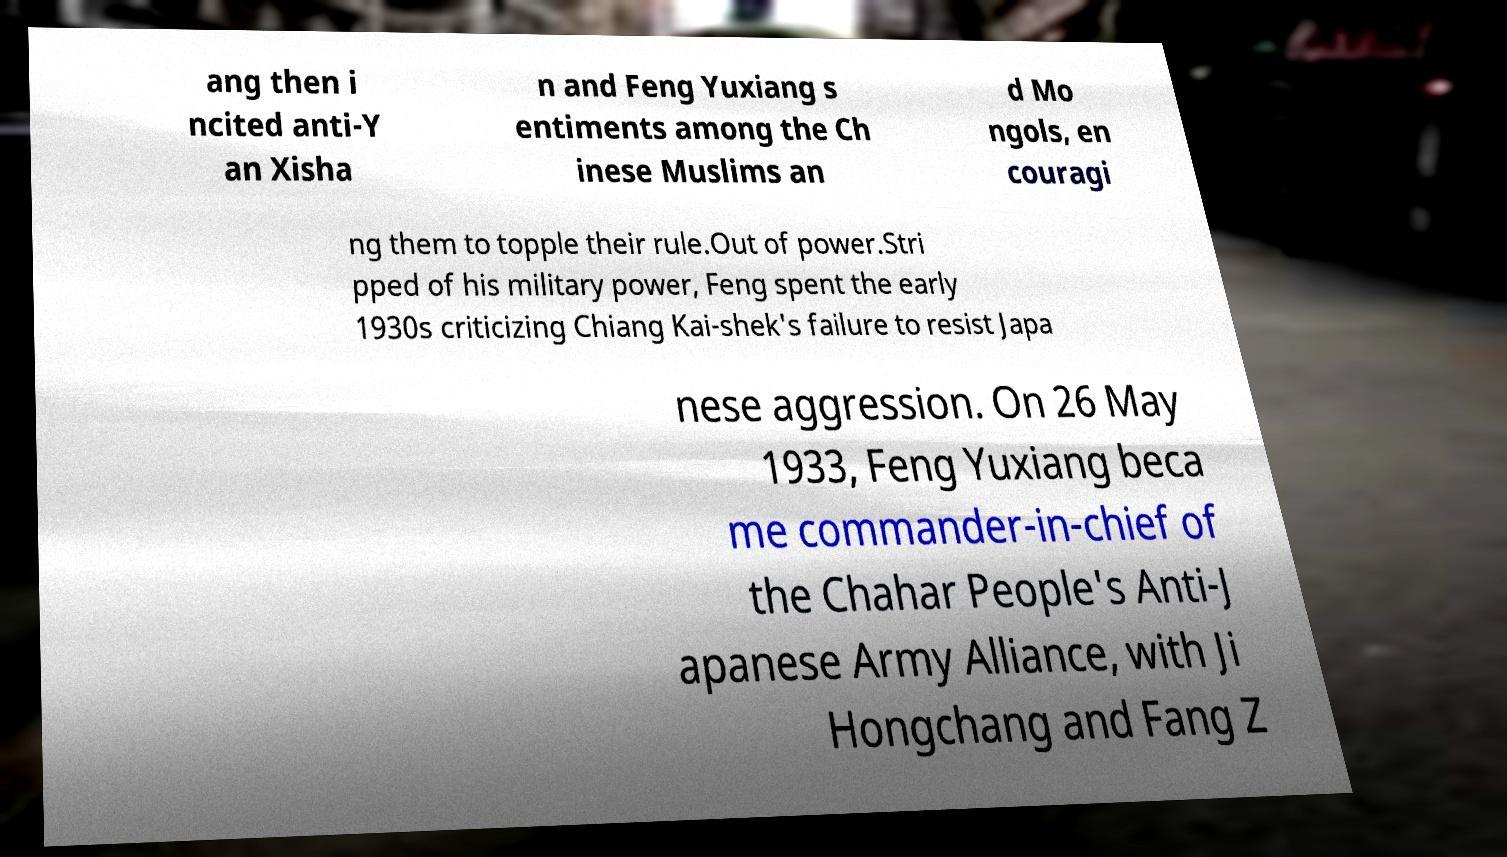For documentation purposes, I need the text within this image transcribed. Could you provide that? ang then i ncited anti-Y an Xisha n and Feng Yuxiang s entiments among the Ch inese Muslims an d Mo ngols, en couragi ng them to topple their rule.Out of power.Stri pped of his military power, Feng spent the early 1930s criticizing Chiang Kai-shek's failure to resist Japa nese aggression. On 26 May 1933, Feng Yuxiang beca me commander-in-chief of the Chahar People's Anti-J apanese Army Alliance, with Ji Hongchang and Fang Z 